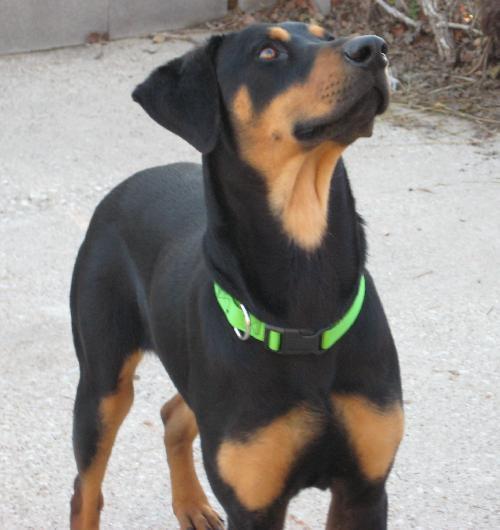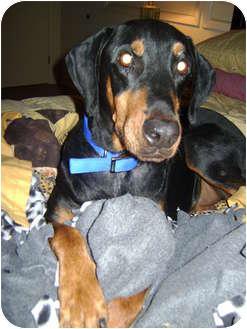The first image is the image on the left, the second image is the image on the right. For the images displayed, is the sentence "A dog is sitting on carpet." factually correct? Answer yes or no. No. 